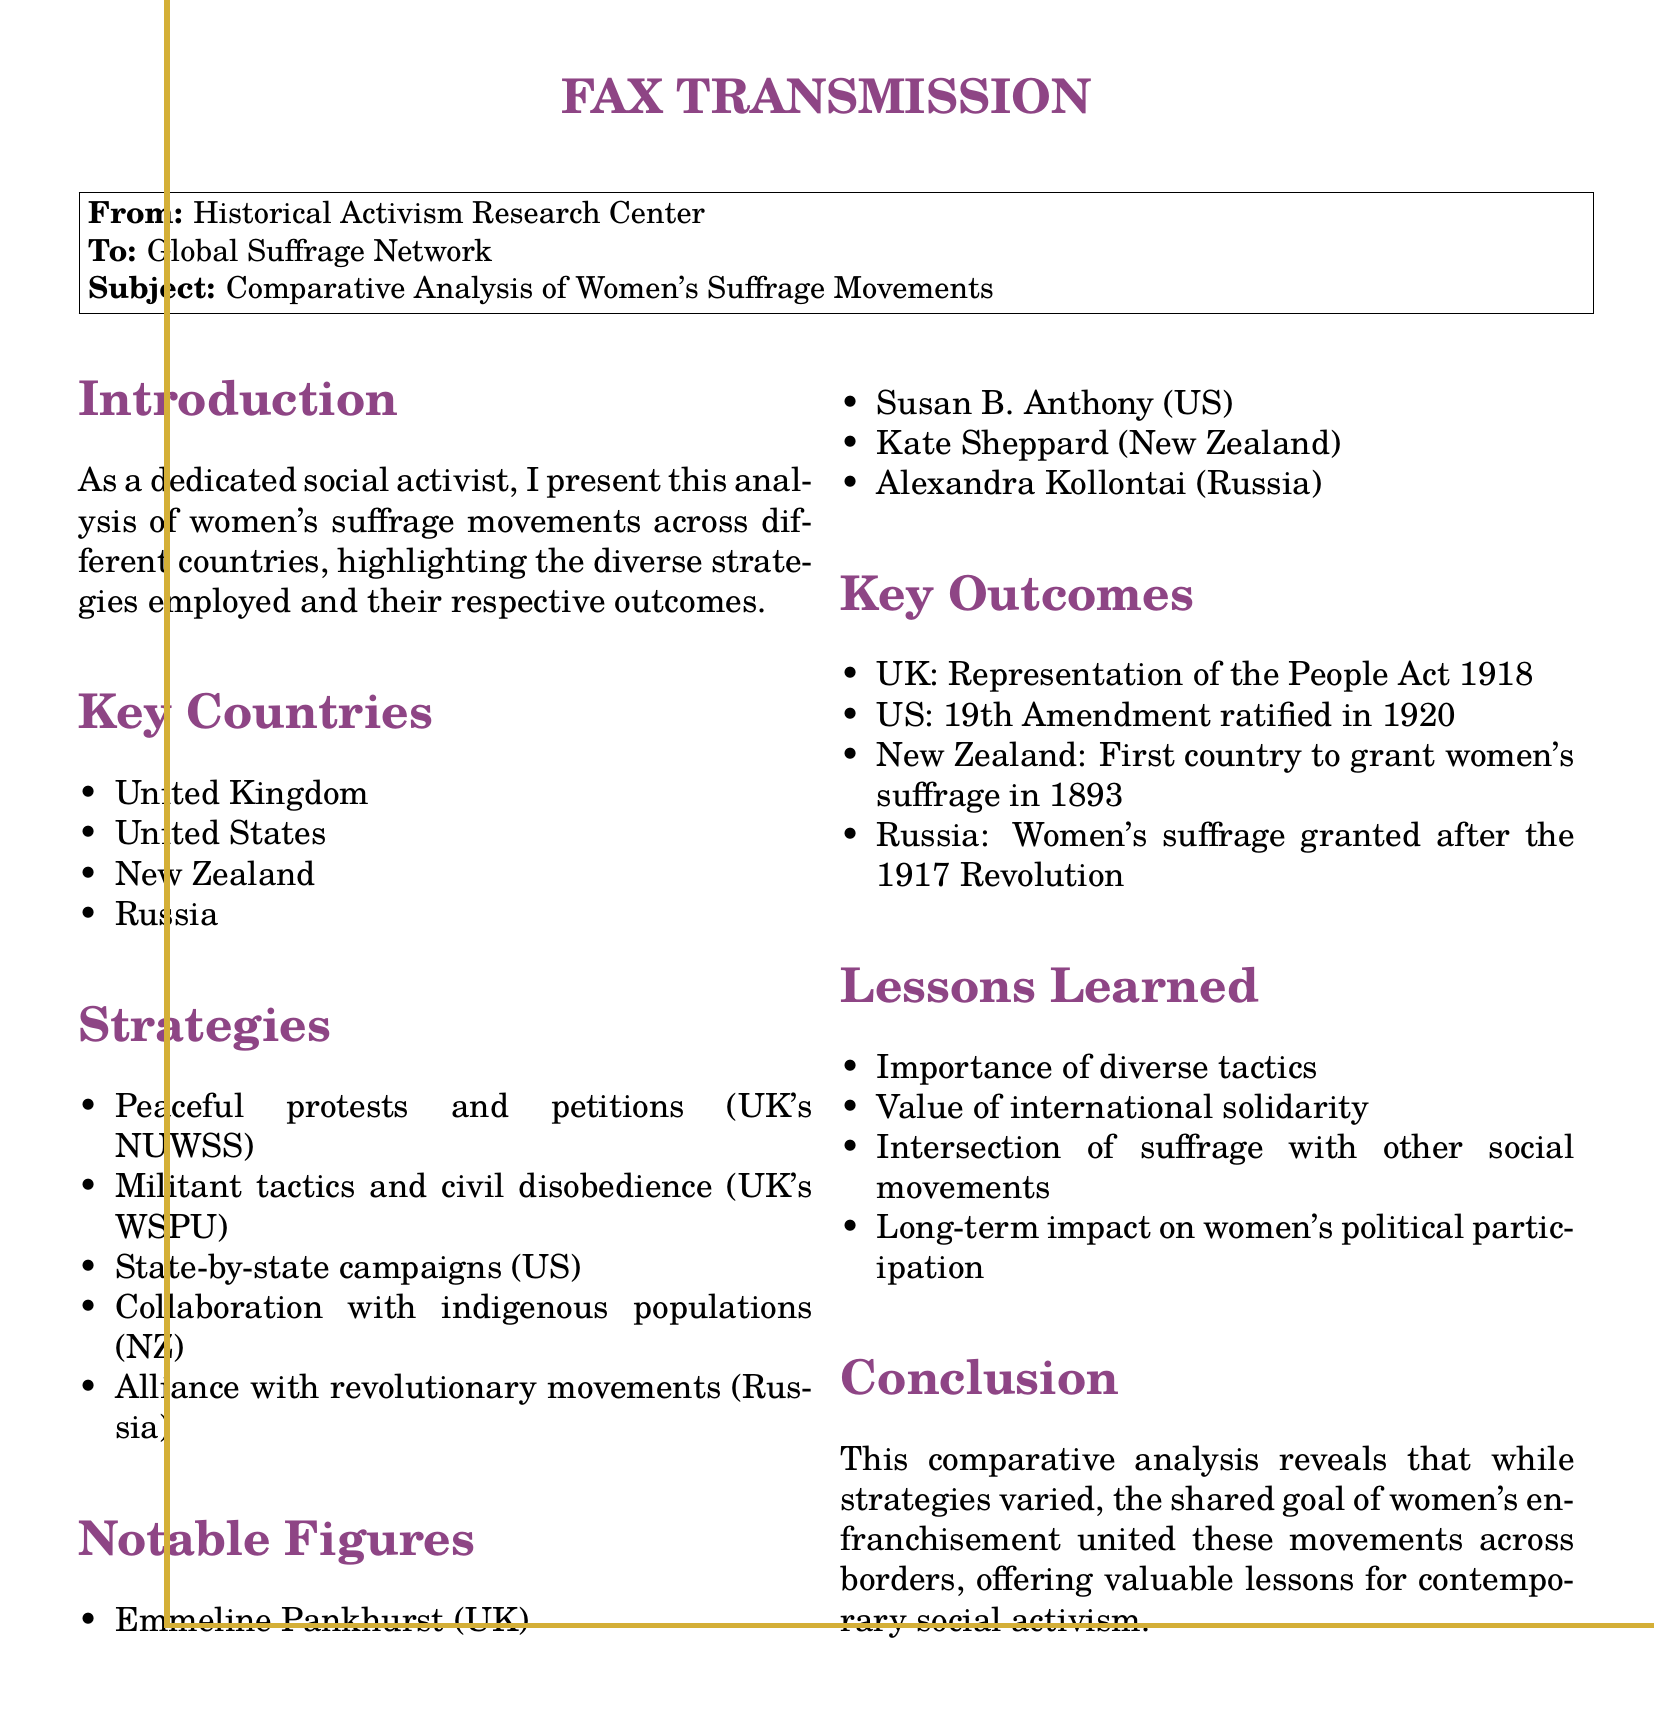what is the first country to grant women's suffrage? The document states that New Zealand was the first country to grant women's suffrage in 1893.
Answer: New Zealand who is a notable figure in the US suffrage movement? The document lists Susan B. Anthony as a notable figure in the US suffrage movement.
Answer: Susan B. Anthony what act granted women's suffrage in the UK? The Representation of the People Act 1918 is mentioned as granting women's suffrage in the UK.
Answer: Representation of the People Act 1918 what was a key strategy used in the UK by the WSPU? The document mentions militant tactics and civil disobedience as a key strategy used by the WSPU in the UK.
Answer: Militant tactics and civil disobedience which country granted women's suffrage after the 1917 Revolution? The document states that Russia granted women's suffrage after the 1917 Revolution.
Answer: Russia what is one lesson learned from the suffrage movements? The document highlights the importance of diverse tactics as one of the lessons learned from the suffrage movements.
Answer: Importance of diverse tactics which notable figure is associated with the suffrage movement in New Zealand? The document identifies Kate Sheppard as the notable figure associated with the suffrage movement in New Zealand.
Answer: Kate Sheppard what type of document is this? The document is classified as a fax transmission.
Answer: Fax transmission 